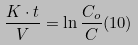Convert formula to latex. <formula><loc_0><loc_0><loc_500><loc_500>\frac { K \cdot t } { V } = \ln \frac { C _ { o } } { C } ( 1 0 )</formula> 